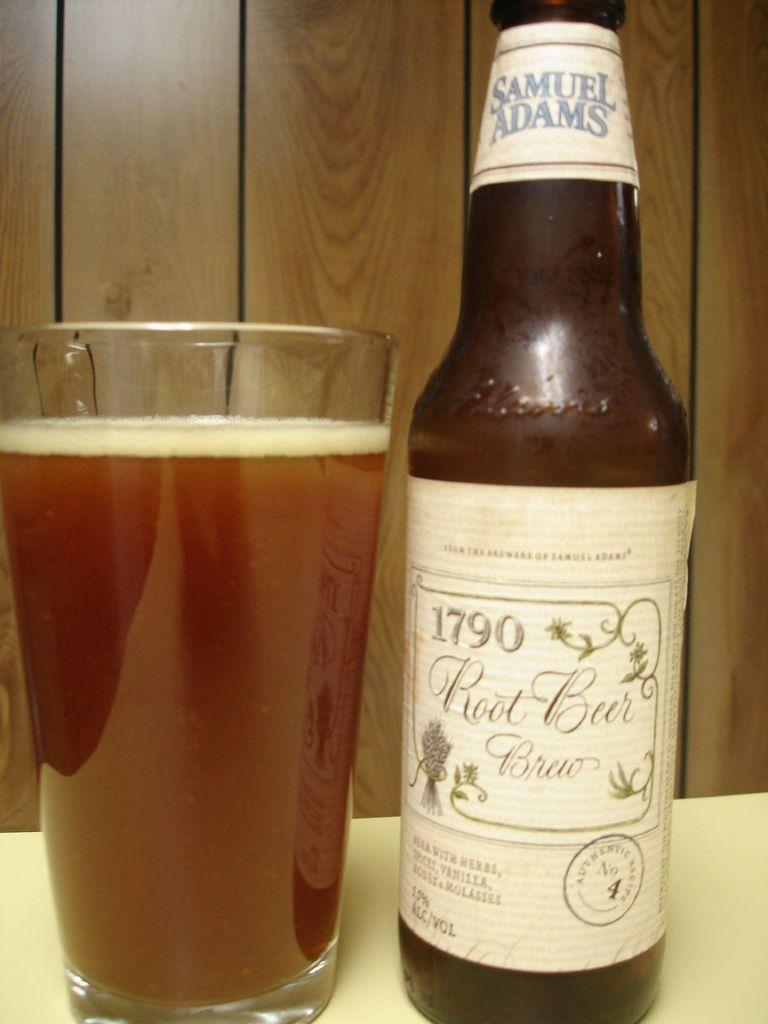<image>
Relay a brief, clear account of the picture shown. A bottle of Samuel Adams beer has the date 1790 on the label. 